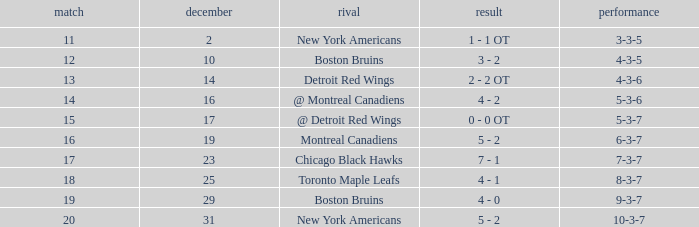Which Game is the highest one that has a Record of 4-3-6? 13.0. 